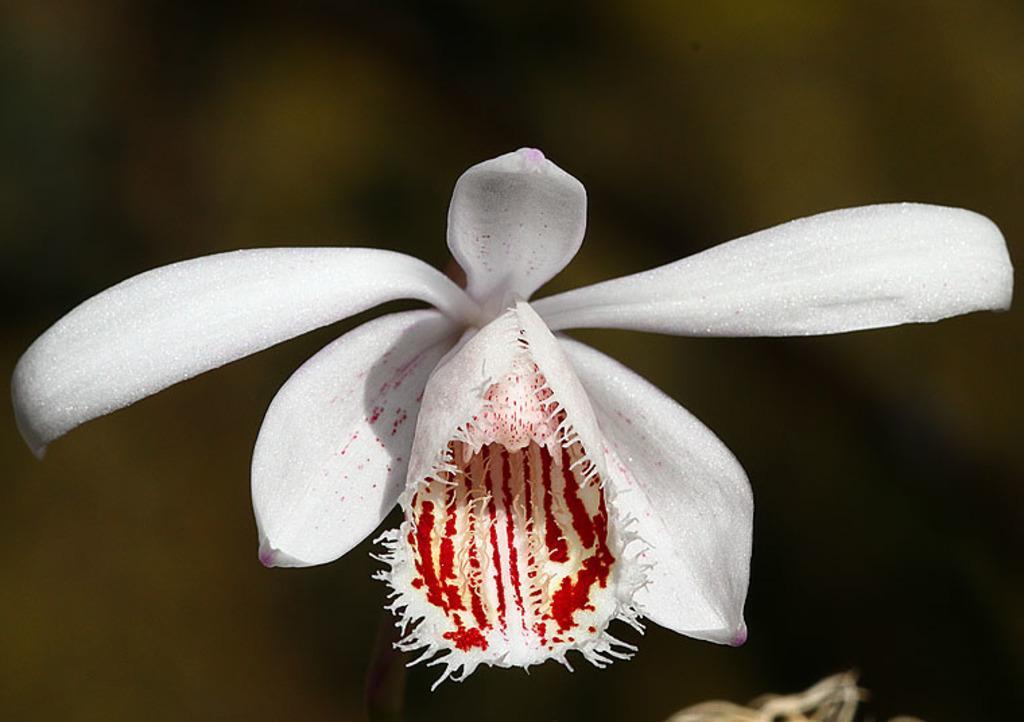Can you describe this image briefly? In the center of the image we can see a flower. 